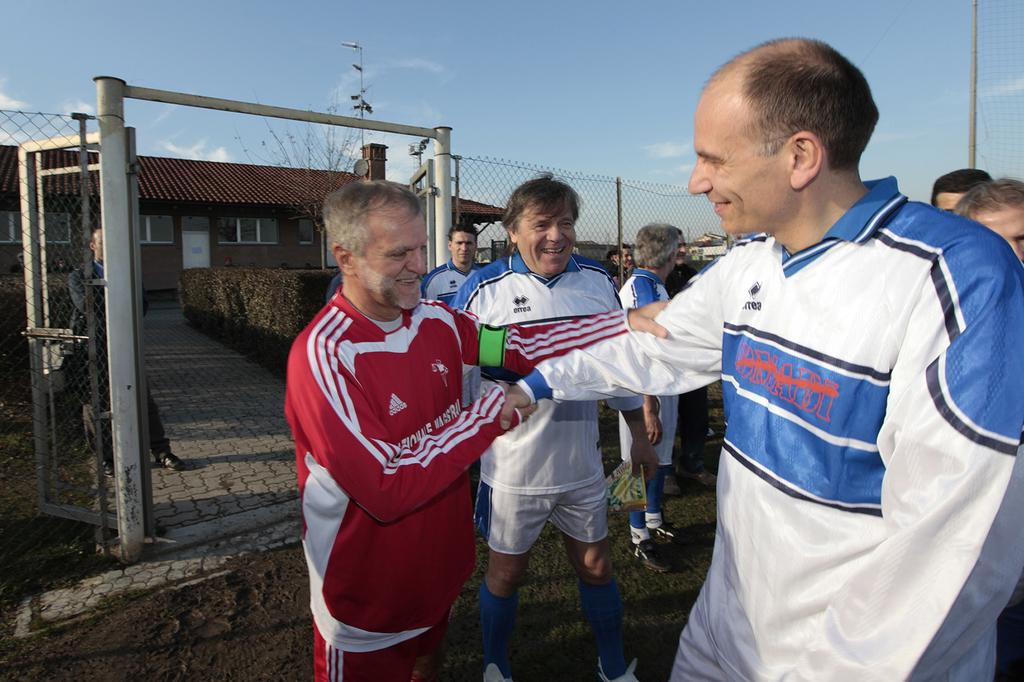<image>
Offer a succinct explanation of the picture presented. A man in a red Adidas track suit embraces another man in a blue and white shirt. 